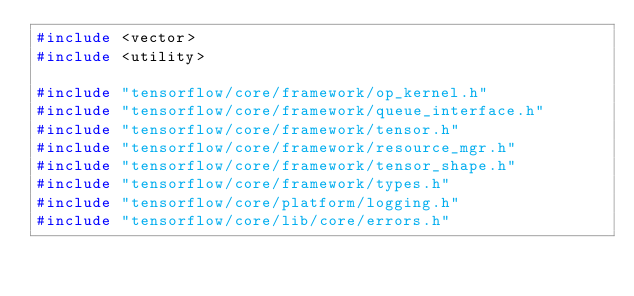Convert code to text. <code><loc_0><loc_0><loc_500><loc_500><_C++_>#include <vector>
#include <utility>

#include "tensorflow/core/framework/op_kernel.h"
#include "tensorflow/core/framework/queue_interface.h"
#include "tensorflow/core/framework/tensor.h"
#include "tensorflow/core/framework/resource_mgr.h"
#include "tensorflow/core/framework/tensor_shape.h"
#include "tensorflow/core/framework/types.h"
#include "tensorflow/core/platform/logging.h"
#include "tensorflow/core/lib/core/errors.h"</code> 